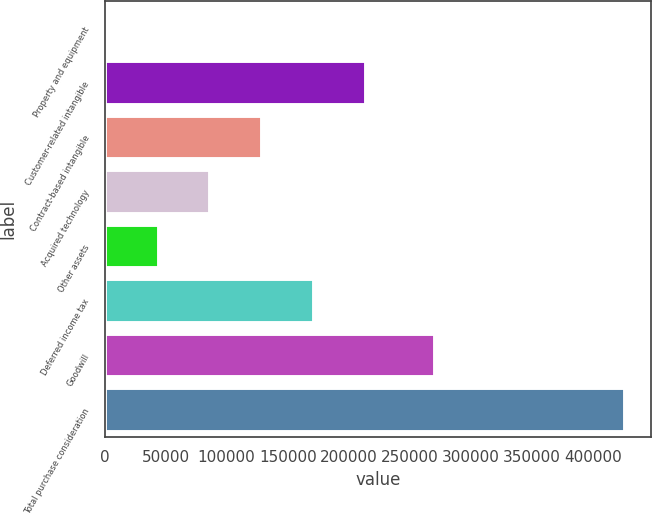Convert chart. <chart><loc_0><loc_0><loc_500><loc_500><bar_chart><fcel>Property and equipment<fcel>Customer-related intangible<fcel>Contract-based intangible<fcel>Acquired technology<fcel>Other assets<fcel>Deferred income tax<fcel>Goodwill<fcel>Total purchase consideration<nl><fcel>1680<fcel>214066<fcel>129112<fcel>86634.4<fcel>44157.2<fcel>171589<fcel>270878<fcel>426452<nl></chart> 